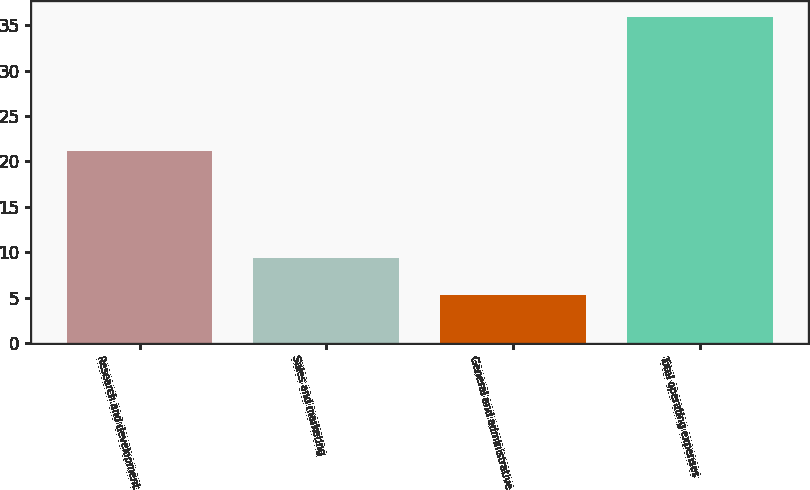Convert chart. <chart><loc_0><loc_0><loc_500><loc_500><bar_chart><fcel>Research and development<fcel>Sales and marketing<fcel>General and administrative<fcel>Total operating expenses<nl><fcel>21.2<fcel>9.4<fcel>5.3<fcel>35.9<nl></chart> 